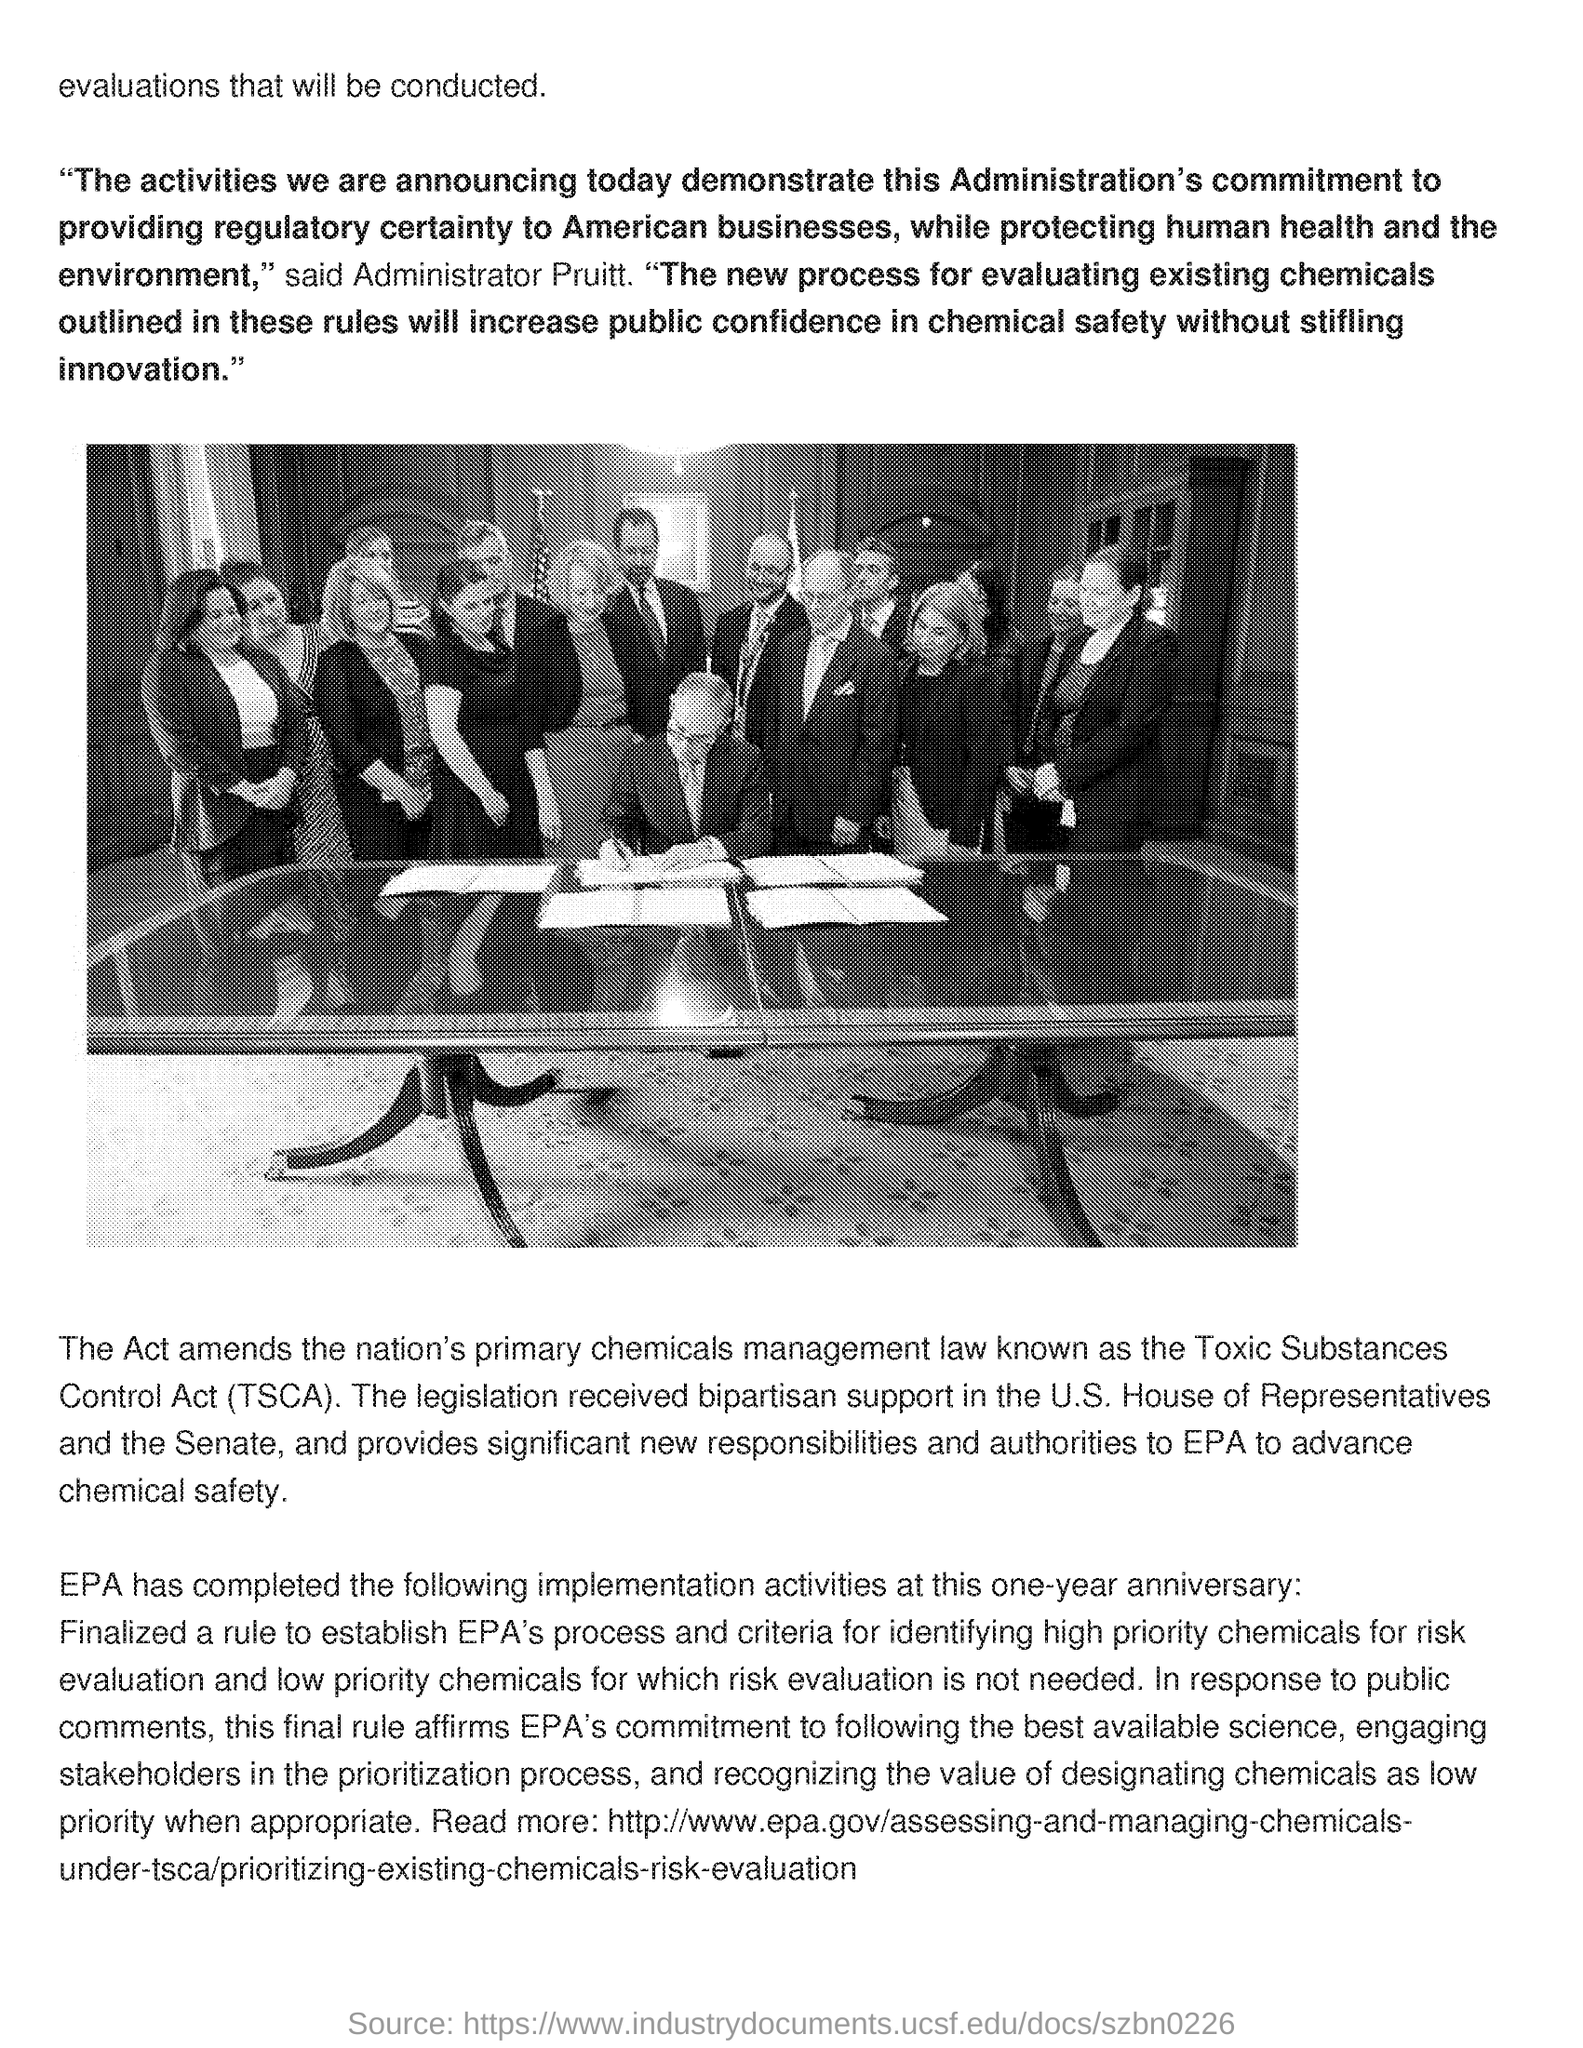Point out several critical features in this image. The Toxic Substances Control Act (TSCA) is a federal law that regulates the use of toxic chemicals in the United States. 